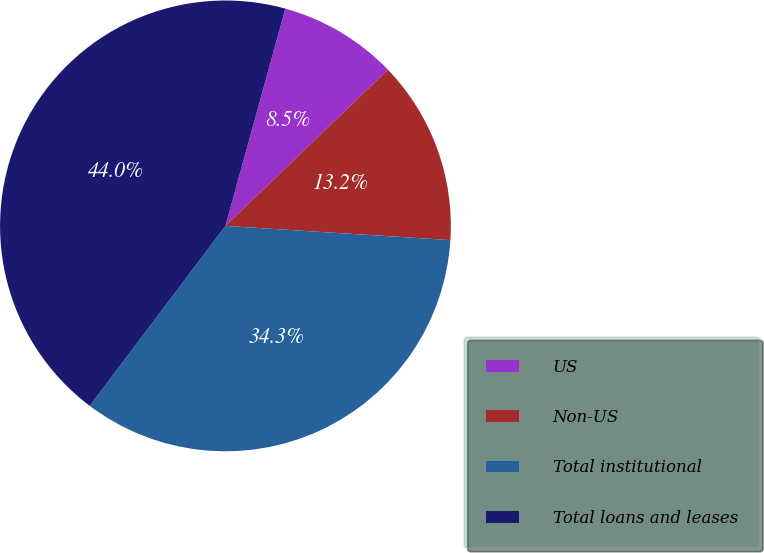Convert chart to OTSL. <chart><loc_0><loc_0><loc_500><loc_500><pie_chart><fcel>US<fcel>Non-US<fcel>Total institutional<fcel>Total loans and leases<nl><fcel>8.53%<fcel>13.19%<fcel>34.28%<fcel>44.0%<nl></chart> 